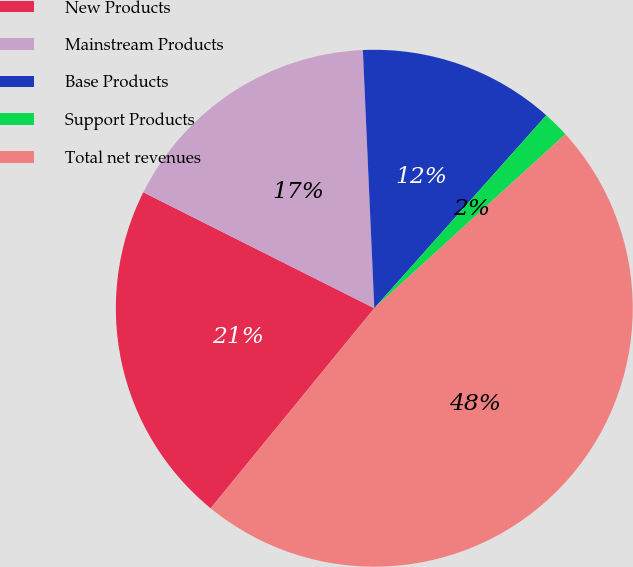<chart> <loc_0><loc_0><loc_500><loc_500><pie_chart><fcel>New Products<fcel>Mainstream Products<fcel>Base Products<fcel>Support Products<fcel>Total net revenues<nl><fcel>21.49%<fcel>16.89%<fcel>12.29%<fcel>1.66%<fcel>47.66%<nl></chart> 